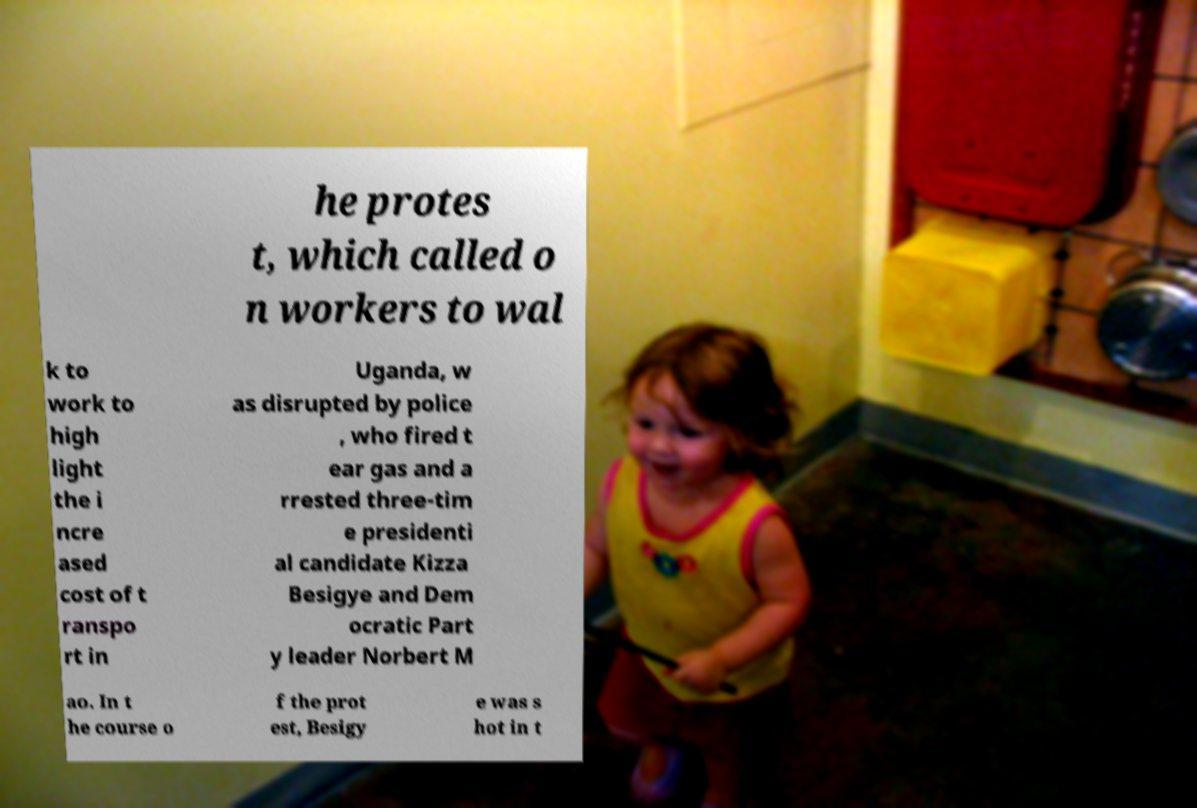For documentation purposes, I need the text within this image transcribed. Could you provide that? he protes t, which called o n workers to wal k to work to high light the i ncre ased cost of t ranspo rt in Uganda, w as disrupted by police , who fired t ear gas and a rrested three-tim e presidenti al candidate Kizza Besigye and Dem ocratic Part y leader Norbert M ao. In t he course o f the prot est, Besigy e was s hot in t 